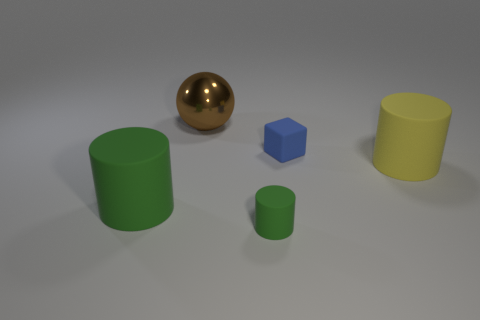What is the material of the object that is the same color as the small rubber cylinder?
Offer a very short reply. Rubber. How many tiny rubber cylinders have the same color as the shiny sphere?
Provide a short and direct response. 0. There is a blue matte thing that is right of the small rubber thing in front of the blue object; what is its shape?
Make the answer very short. Cube. Is there a big blue rubber thing of the same shape as the large brown thing?
Provide a succinct answer. No. There is a tiny matte block; is it the same color as the big rubber cylinder that is in front of the big yellow cylinder?
Ensure brevity in your answer.  No. What is the size of the object that is the same color as the small rubber cylinder?
Give a very brief answer. Large. Are there any cyan blocks that have the same size as the brown thing?
Ensure brevity in your answer.  No. Is the material of the tiny green object the same as the large yellow thing that is to the right of the sphere?
Offer a terse response. Yes. Are there more tiny rubber cubes than green matte objects?
Make the answer very short. No. How many cylinders are either rubber objects or small matte objects?
Your response must be concise. 3. 